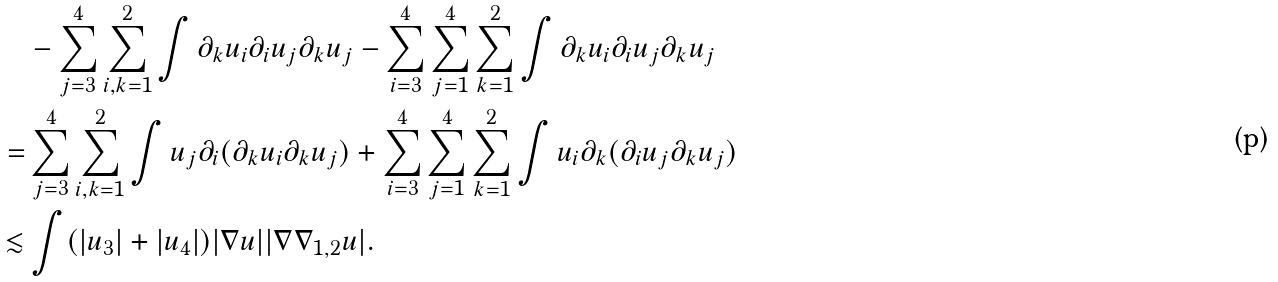Convert formula to latex. <formula><loc_0><loc_0><loc_500><loc_500>& - \sum _ { j = 3 } ^ { 4 } \sum _ { i , k = 1 } ^ { 2 } \int \partial _ { k } u _ { i } \partial _ { i } u _ { j } \partial _ { k } u _ { j } - \sum _ { i = 3 } ^ { 4 } \sum _ { j = 1 } ^ { 4 } \sum _ { k = 1 } ^ { 2 } \int \partial _ { k } u _ { i } \partial _ { i } u _ { j } \partial _ { k } u _ { j } \\ = & \sum _ { j = 3 } ^ { 4 } \sum _ { i , k = 1 } ^ { 2 } \int u _ { j } \partial _ { i } ( \partial _ { k } u _ { i } \partial _ { k } u _ { j } ) + \sum _ { i = 3 } ^ { 4 } \sum _ { j = 1 } ^ { 4 } \sum _ { k = 1 } ^ { 2 } \int u _ { i } \partial _ { k } ( \partial _ { i } u _ { j } \partial _ { k } u _ { j } ) \\ \lesssim & \int ( | u _ { 3 } | + | u _ { 4 } | ) | \nabla u | | \nabla \nabla _ { 1 , 2 } u | .</formula> 